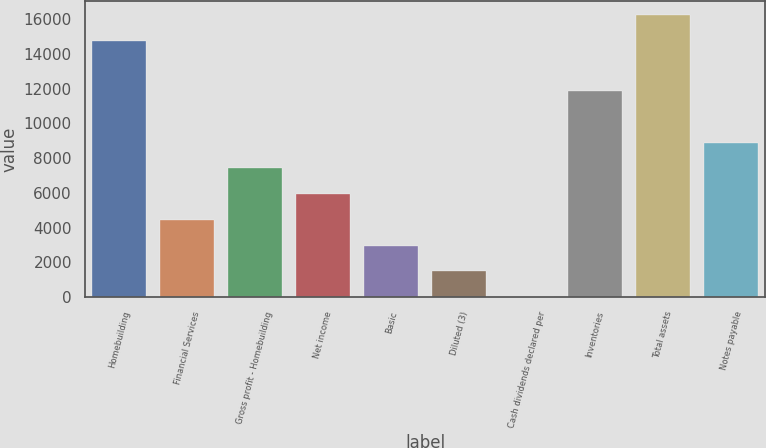Convert chart. <chart><loc_0><loc_0><loc_500><loc_500><bar_chart><fcel>Homebuilding<fcel>Financial Services<fcel>Gross profit - Homebuilding<fcel>Net income<fcel>Basic<fcel>Diluted (3)<fcel>Cash dividends declared per<fcel>Inventories<fcel>Total assets<fcel>Notes payable<nl><fcel>14760.5<fcel>4446.53<fcel>7410.59<fcel>5928.56<fcel>2964.5<fcel>1482.47<fcel>0.44<fcel>11856.7<fcel>16242.5<fcel>8892.62<nl></chart> 